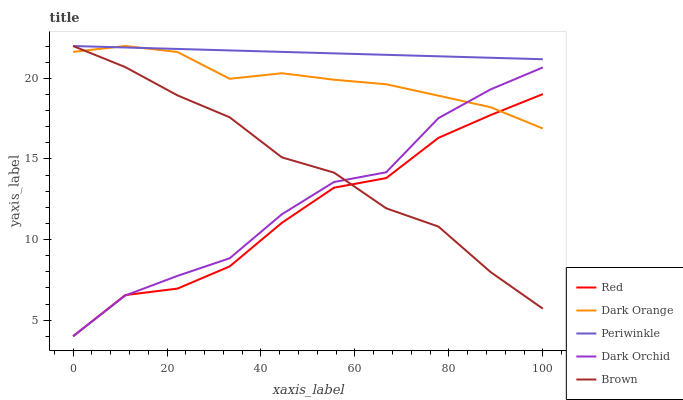Does Dark Orchid have the minimum area under the curve?
Answer yes or no. No. Does Dark Orchid have the maximum area under the curve?
Answer yes or no. No. Is Dark Orchid the smoothest?
Answer yes or no. No. Is Periwinkle the roughest?
Answer yes or no. No. Does Periwinkle have the lowest value?
Answer yes or no. No. Does Dark Orchid have the highest value?
Answer yes or no. No. Is Red less than Periwinkle?
Answer yes or no. Yes. Is Periwinkle greater than Red?
Answer yes or no. Yes. Does Red intersect Periwinkle?
Answer yes or no. No. 